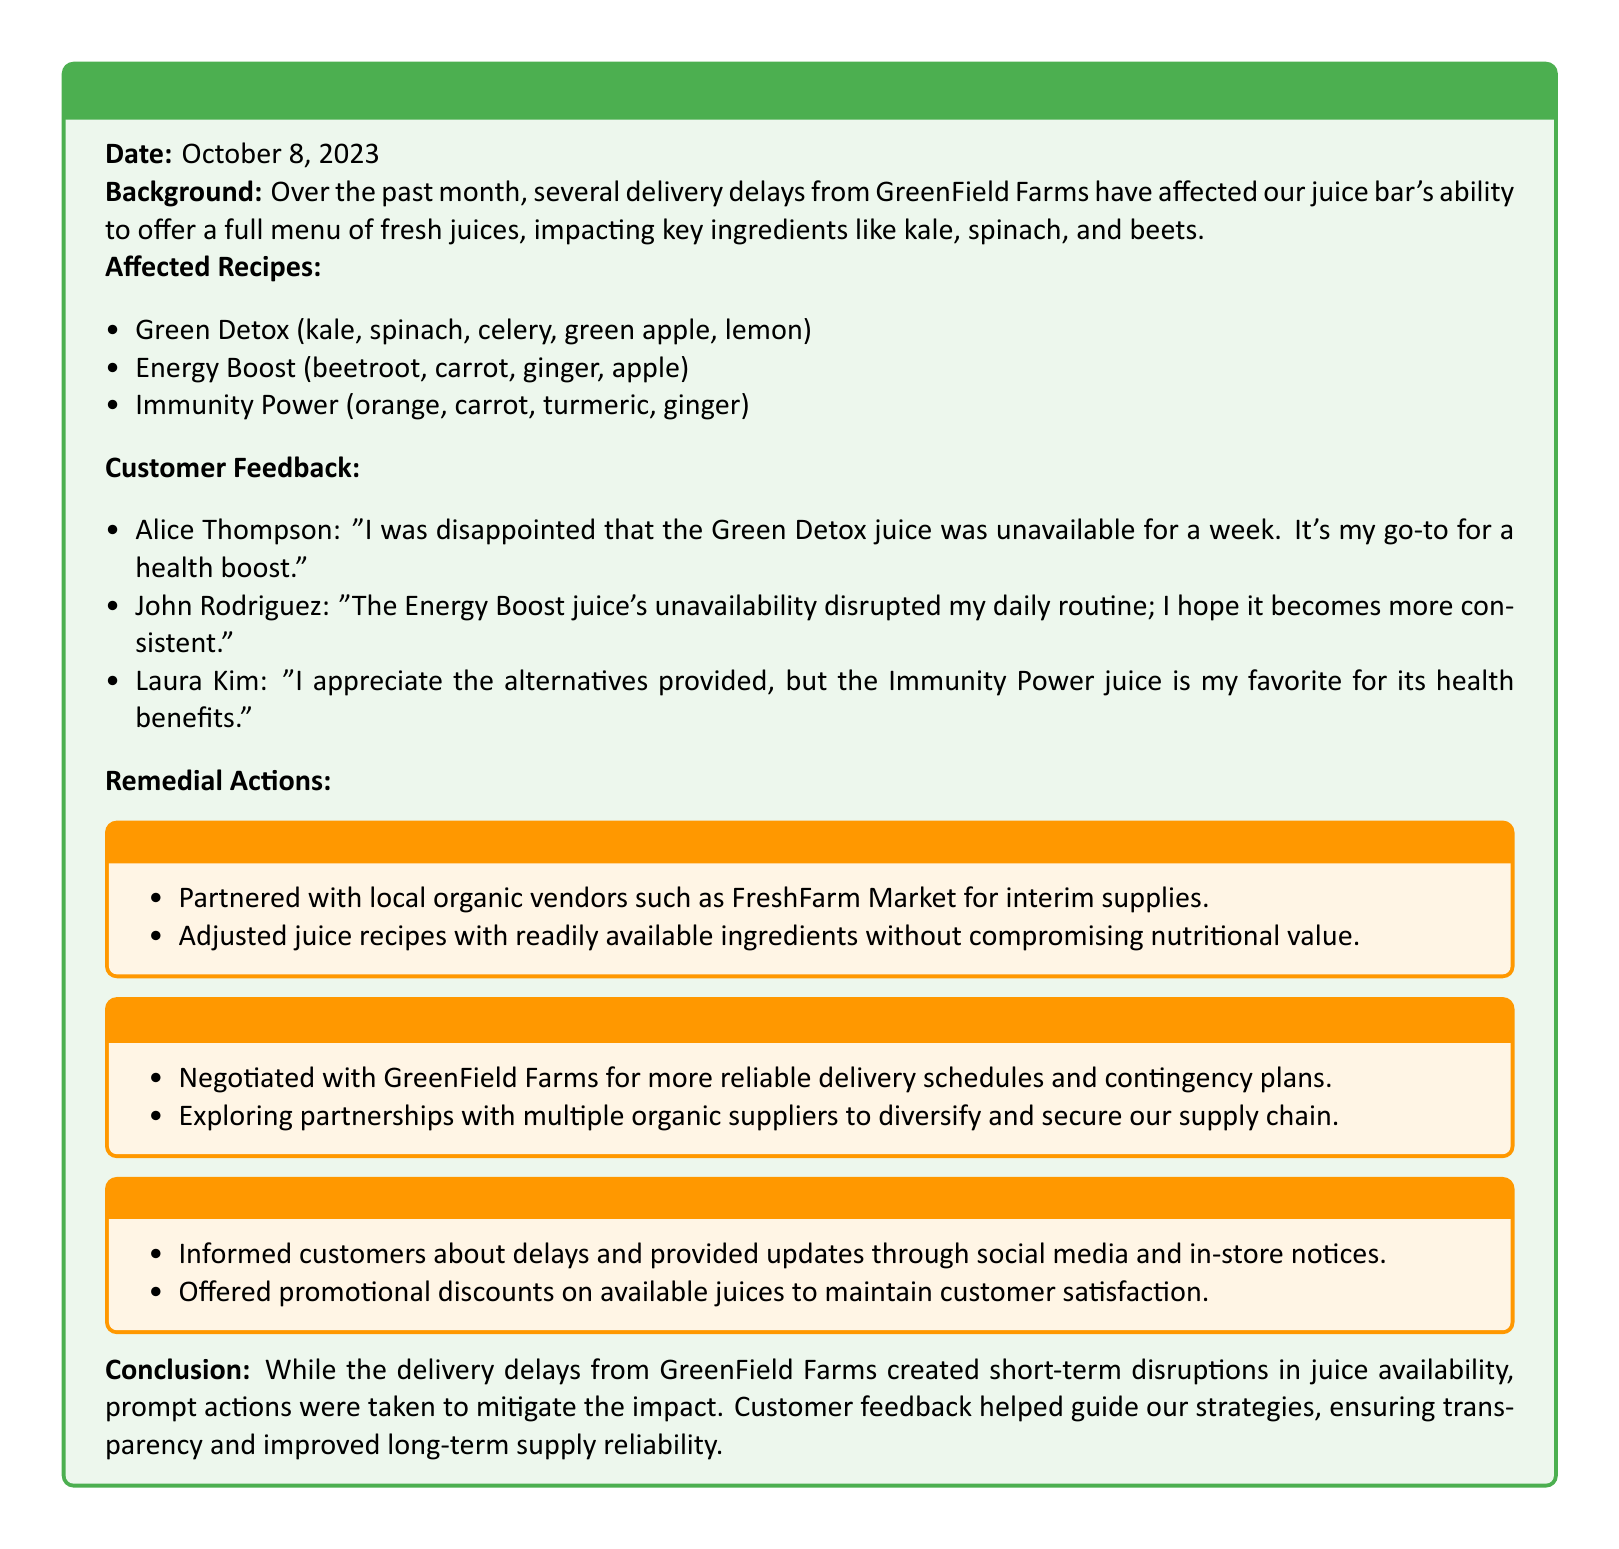What is the date of the incident report? The date of the incident report is stated at the beginning of the document.
Answer: October 8, 2023 What are the key ingredients affected by the delivery delays? The key ingredients that were affected by delivery delays include kale, spinach, and beets, which are mentioned in the background section.
Answer: Kale, spinach, beets Who expressed disappointment about the Green Detox juice? The document lists customer feedback, and Alice Thompson specifically mentions her disappointment.
Answer: Alice Thompson What short-term action was taken regarding juice ingredient supply? The remedial actions section outlines several strategies, one involving partnering with local organic vendors.
Answer: Partnered with local organic vendors How many affected juice recipes are listed in the document? The number of affected juice recipes can be counted in the affected recipes list provided.
Answer: Three What long-term action involves negotiating schedules? The document specifies that negotiations were made with GreenField Farms for more reliable delivery schedules.
Answer: Negotiated with GreenField Farms What type of communication was used to inform customers about delays? The communication section includes informing customers through social media and in-store notices.
Answer: Social media and in-store notices Which juice was mentioned for its health benefits by a customer? Laura Kim mentioned the Immunity Power juice specifically for its health benefits.
Answer: Immunity Power What promotional strategy was used to maintain customer satisfaction? The document notes that promotional discounts on available juices were offered to maintain satisfaction.
Answer: Promotional discounts 